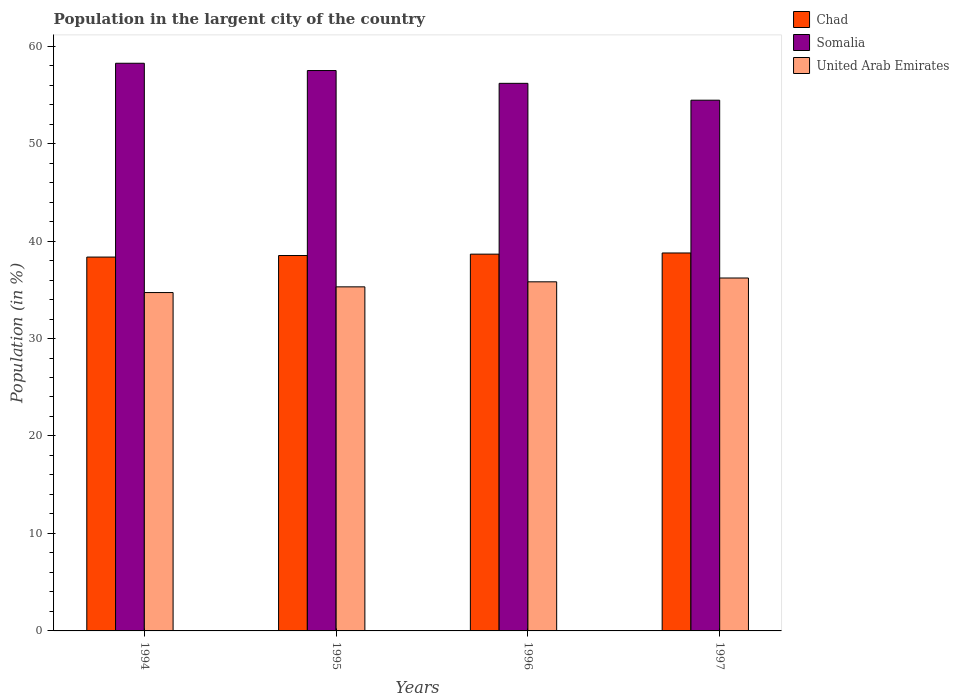Are the number of bars per tick equal to the number of legend labels?
Make the answer very short. Yes. How many bars are there on the 1st tick from the left?
Offer a terse response. 3. In how many cases, is the number of bars for a given year not equal to the number of legend labels?
Give a very brief answer. 0. What is the percentage of population in the largent city in Chad in 1996?
Ensure brevity in your answer.  38.66. Across all years, what is the maximum percentage of population in the largent city in Chad?
Ensure brevity in your answer.  38.78. Across all years, what is the minimum percentage of population in the largent city in Chad?
Make the answer very short. 38.36. In which year was the percentage of population in the largent city in Chad minimum?
Provide a short and direct response. 1994. What is the total percentage of population in the largent city in Somalia in the graph?
Your answer should be compact. 226.36. What is the difference between the percentage of population in the largent city in Somalia in 1995 and that in 1996?
Offer a terse response. 1.31. What is the difference between the percentage of population in the largent city in Chad in 1997 and the percentage of population in the largent city in United Arab Emirates in 1996?
Ensure brevity in your answer.  2.96. What is the average percentage of population in the largent city in United Arab Emirates per year?
Make the answer very short. 35.51. In the year 1994, what is the difference between the percentage of population in the largent city in Chad and percentage of population in the largent city in Somalia?
Your answer should be very brief. -19.88. In how many years, is the percentage of population in the largent city in United Arab Emirates greater than 14 %?
Provide a succinct answer. 4. What is the ratio of the percentage of population in the largent city in United Arab Emirates in 1994 to that in 1996?
Keep it short and to the point. 0.97. Is the difference between the percentage of population in the largent city in Chad in 1994 and 1995 greater than the difference between the percentage of population in the largent city in Somalia in 1994 and 1995?
Keep it short and to the point. No. What is the difference between the highest and the second highest percentage of population in the largent city in Somalia?
Provide a succinct answer. 0.75. What is the difference between the highest and the lowest percentage of population in the largent city in Somalia?
Offer a very short reply. 3.79. In how many years, is the percentage of population in the largent city in United Arab Emirates greater than the average percentage of population in the largent city in United Arab Emirates taken over all years?
Provide a succinct answer. 2. What does the 1st bar from the left in 1997 represents?
Your answer should be compact. Chad. What does the 3rd bar from the right in 1994 represents?
Your answer should be compact. Chad. Is it the case that in every year, the sum of the percentage of population in the largent city in United Arab Emirates and percentage of population in the largent city in Chad is greater than the percentage of population in the largent city in Somalia?
Make the answer very short. Yes. What is the difference between two consecutive major ticks on the Y-axis?
Provide a succinct answer. 10. Are the values on the major ticks of Y-axis written in scientific E-notation?
Your answer should be compact. No. Does the graph contain any zero values?
Give a very brief answer. No. Where does the legend appear in the graph?
Provide a succinct answer. Top right. How many legend labels are there?
Ensure brevity in your answer.  3. What is the title of the graph?
Provide a succinct answer. Population in the largent city of the country. Does "Belize" appear as one of the legend labels in the graph?
Your answer should be compact. No. What is the Population (in %) in Chad in 1994?
Your response must be concise. 38.36. What is the Population (in %) of Somalia in 1994?
Make the answer very short. 58.24. What is the Population (in %) in United Arab Emirates in 1994?
Provide a succinct answer. 34.71. What is the Population (in %) in Chad in 1995?
Your response must be concise. 38.51. What is the Population (in %) in Somalia in 1995?
Provide a short and direct response. 57.49. What is the Population (in %) in United Arab Emirates in 1995?
Provide a succinct answer. 35.3. What is the Population (in %) in Chad in 1996?
Offer a terse response. 38.66. What is the Population (in %) in Somalia in 1996?
Offer a terse response. 56.18. What is the Population (in %) of United Arab Emirates in 1996?
Your response must be concise. 35.82. What is the Population (in %) of Chad in 1997?
Offer a very short reply. 38.78. What is the Population (in %) in Somalia in 1997?
Your response must be concise. 54.45. What is the Population (in %) in United Arab Emirates in 1997?
Offer a very short reply. 36.21. Across all years, what is the maximum Population (in %) in Chad?
Your answer should be very brief. 38.78. Across all years, what is the maximum Population (in %) in Somalia?
Your answer should be compact. 58.24. Across all years, what is the maximum Population (in %) in United Arab Emirates?
Ensure brevity in your answer.  36.21. Across all years, what is the minimum Population (in %) of Chad?
Your response must be concise. 38.36. Across all years, what is the minimum Population (in %) in Somalia?
Keep it short and to the point. 54.45. Across all years, what is the minimum Population (in %) in United Arab Emirates?
Your answer should be compact. 34.71. What is the total Population (in %) of Chad in the graph?
Offer a terse response. 154.3. What is the total Population (in %) in Somalia in the graph?
Give a very brief answer. 226.36. What is the total Population (in %) of United Arab Emirates in the graph?
Provide a succinct answer. 142.04. What is the difference between the Population (in %) in Chad in 1994 and that in 1995?
Provide a succinct answer. -0.16. What is the difference between the Population (in %) of Somalia in 1994 and that in 1995?
Keep it short and to the point. 0.75. What is the difference between the Population (in %) of United Arab Emirates in 1994 and that in 1995?
Offer a terse response. -0.59. What is the difference between the Population (in %) of Chad in 1994 and that in 1996?
Offer a terse response. -0.3. What is the difference between the Population (in %) in Somalia in 1994 and that in 1996?
Provide a short and direct response. 2.06. What is the difference between the Population (in %) of United Arab Emirates in 1994 and that in 1996?
Your response must be concise. -1.1. What is the difference between the Population (in %) in Chad in 1994 and that in 1997?
Provide a short and direct response. -0.42. What is the difference between the Population (in %) in Somalia in 1994 and that in 1997?
Keep it short and to the point. 3.79. What is the difference between the Population (in %) in United Arab Emirates in 1994 and that in 1997?
Offer a very short reply. -1.49. What is the difference between the Population (in %) of Chad in 1995 and that in 1996?
Your answer should be very brief. -0.14. What is the difference between the Population (in %) in Somalia in 1995 and that in 1996?
Provide a succinct answer. 1.31. What is the difference between the Population (in %) of United Arab Emirates in 1995 and that in 1996?
Your answer should be very brief. -0.52. What is the difference between the Population (in %) in Chad in 1995 and that in 1997?
Make the answer very short. -0.26. What is the difference between the Population (in %) of Somalia in 1995 and that in 1997?
Make the answer very short. 3.04. What is the difference between the Population (in %) in United Arab Emirates in 1995 and that in 1997?
Offer a very short reply. -0.91. What is the difference between the Population (in %) in Chad in 1996 and that in 1997?
Provide a succinct answer. -0.12. What is the difference between the Population (in %) in Somalia in 1996 and that in 1997?
Give a very brief answer. 1.73. What is the difference between the Population (in %) of United Arab Emirates in 1996 and that in 1997?
Your answer should be very brief. -0.39. What is the difference between the Population (in %) of Chad in 1994 and the Population (in %) of Somalia in 1995?
Make the answer very short. -19.14. What is the difference between the Population (in %) of Chad in 1994 and the Population (in %) of United Arab Emirates in 1995?
Provide a succinct answer. 3.05. What is the difference between the Population (in %) of Somalia in 1994 and the Population (in %) of United Arab Emirates in 1995?
Your answer should be compact. 22.94. What is the difference between the Population (in %) of Chad in 1994 and the Population (in %) of Somalia in 1996?
Your answer should be compact. -17.82. What is the difference between the Population (in %) in Chad in 1994 and the Population (in %) in United Arab Emirates in 1996?
Provide a succinct answer. 2.54. What is the difference between the Population (in %) in Somalia in 1994 and the Population (in %) in United Arab Emirates in 1996?
Give a very brief answer. 22.42. What is the difference between the Population (in %) of Chad in 1994 and the Population (in %) of Somalia in 1997?
Give a very brief answer. -16.09. What is the difference between the Population (in %) of Chad in 1994 and the Population (in %) of United Arab Emirates in 1997?
Your answer should be very brief. 2.15. What is the difference between the Population (in %) in Somalia in 1994 and the Population (in %) in United Arab Emirates in 1997?
Your answer should be compact. 22.03. What is the difference between the Population (in %) in Chad in 1995 and the Population (in %) in Somalia in 1996?
Offer a very short reply. -17.66. What is the difference between the Population (in %) of Chad in 1995 and the Population (in %) of United Arab Emirates in 1996?
Make the answer very short. 2.7. What is the difference between the Population (in %) of Somalia in 1995 and the Population (in %) of United Arab Emirates in 1996?
Give a very brief answer. 21.68. What is the difference between the Population (in %) in Chad in 1995 and the Population (in %) in Somalia in 1997?
Provide a short and direct response. -15.94. What is the difference between the Population (in %) of Chad in 1995 and the Population (in %) of United Arab Emirates in 1997?
Your response must be concise. 2.31. What is the difference between the Population (in %) of Somalia in 1995 and the Population (in %) of United Arab Emirates in 1997?
Make the answer very short. 21.28. What is the difference between the Population (in %) of Chad in 1996 and the Population (in %) of Somalia in 1997?
Keep it short and to the point. -15.79. What is the difference between the Population (in %) in Chad in 1996 and the Population (in %) in United Arab Emirates in 1997?
Your answer should be very brief. 2.45. What is the difference between the Population (in %) in Somalia in 1996 and the Population (in %) in United Arab Emirates in 1997?
Your response must be concise. 19.97. What is the average Population (in %) in Chad per year?
Offer a terse response. 38.58. What is the average Population (in %) in Somalia per year?
Keep it short and to the point. 56.59. What is the average Population (in %) in United Arab Emirates per year?
Your answer should be compact. 35.51. In the year 1994, what is the difference between the Population (in %) of Chad and Population (in %) of Somalia?
Make the answer very short. -19.88. In the year 1994, what is the difference between the Population (in %) in Chad and Population (in %) in United Arab Emirates?
Provide a short and direct response. 3.64. In the year 1994, what is the difference between the Population (in %) in Somalia and Population (in %) in United Arab Emirates?
Keep it short and to the point. 23.53. In the year 1995, what is the difference between the Population (in %) in Chad and Population (in %) in Somalia?
Your answer should be very brief. -18.98. In the year 1995, what is the difference between the Population (in %) in Chad and Population (in %) in United Arab Emirates?
Provide a short and direct response. 3.21. In the year 1995, what is the difference between the Population (in %) of Somalia and Population (in %) of United Arab Emirates?
Make the answer very short. 22.19. In the year 1996, what is the difference between the Population (in %) in Chad and Population (in %) in Somalia?
Your answer should be very brief. -17.52. In the year 1996, what is the difference between the Population (in %) in Chad and Population (in %) in United Arab Emirates?
Your answer should be very brief. 2.84. In the year 1996, what is the difference between the Population (in %) of Somalia and Population (in %) of United Arab Emirates?
Your answer should be very brief. 20.36. In the year 1997, what is the difference between the Population (in %) in Chad and Population (in %) in Somalia?
Ensure brevity in your answer.  -15.67. In the year 1997, what is the difference between the Population (in %) in Chad and Population (in %) in United Arab Emirates?
Give a very brief answer. 2.57. In the year 1997, what is the difference between the Population (in %) in Somalia and Population (in %) in United Arab Emirates?
Ensure brevity in your answer.  18.24. What is the ratio of the Population (in %) in Somalia in 1994 to that in 1995?
Offer a terse response. 1.01. What is the ratio of the Population (in %) of United Arab Emirates in 1994 to that in 1995?
Your answer should be very brief. 0.98. What is the ratio of the Population (in %) of Chad in 1994 to that in 1996?
Keep it short and to the point. 0.99. What is the ratio of the Population (in %) in Somalia in 1994 to that in 1996?
Provide a succinct answer. 1.04. What is the ratio of the Population (in %) in United Arab Emirates in 1994 to that in 1996?
Offer a very short reply. 0.97. What is the ratio of the Population (in %) of Chad in 1994 to that in 1997?
Offer a very short reply. 0.99. What is the ratio of the Population (in %) of Somalia in 1994 to that in 1997?
Provide a succinct answer. 1.07. What is the ratio of the Population (in %) in United Arab Emirates in 1994 to that in 1997?
Make the answer very short. 0.96. What is the ratio of the Population (in %) in Somalia in 1995 to that in 1996?
Your answer should be very brief. 1.02. What is the ratio of the Population (in %) in United Arab Emirates in 1995 to that in 1996?
Your answer should be compact. 0.99. What is the ratio of the Population (in %) in Somalia in 1995 to that in 1997?
Make the answer very short. 1.06. What is the ratio of the Population (in %) of United Arab Emirates in 1995 to that in 1997?
Provide a short and direct response. 0.97. What is the ratio of the Population (in %) of Somalia in 1996 to that in 1997?
Offer a terse response. 1.03. What is the difference between the highest and the second highest Population (in %) of Chad?
Offer a very short reply. 0.12. What is the difference between the highest and the second highest Population (in %) of Somalia?
Keep it short and to the point. 0.75. What is the difference between the highest and the second highest Population (in %) in United Arab Emirates?
Offer a terse response. 0.39. What is the difference between the highest and the lowest Population (in %) in Chad?
Provide a short and direct response. 0.42. What is the difference between the highest and the lowest Population (in %) in Somalia?
Offer a very short reply. 3.79. What is the difference between the highest and the lowest Population (in %) in United Arab Emirates?
Offer a terse response. 1.49. 